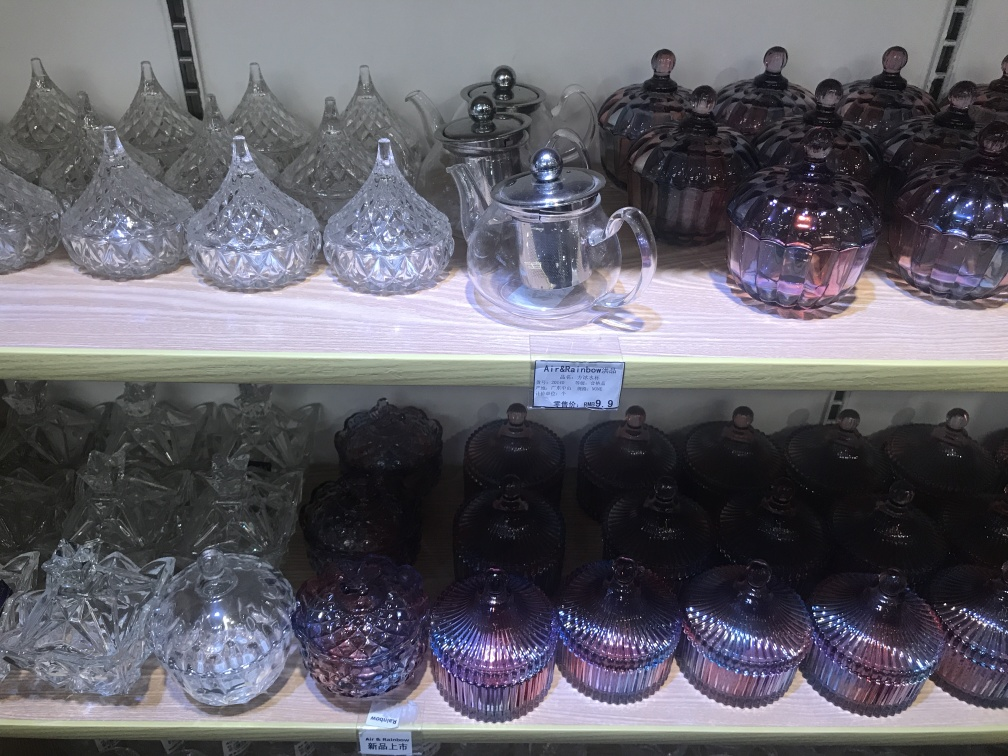How would you describe the style of the items seen here? The style of the items in the image can be described as classical with a modern twist, embodying intricate patterns reminiscent of traditional cut crystal glassware, while some pieces, particularly those with an iridescent finish, add a contemporary, stylish flair to the collection. 